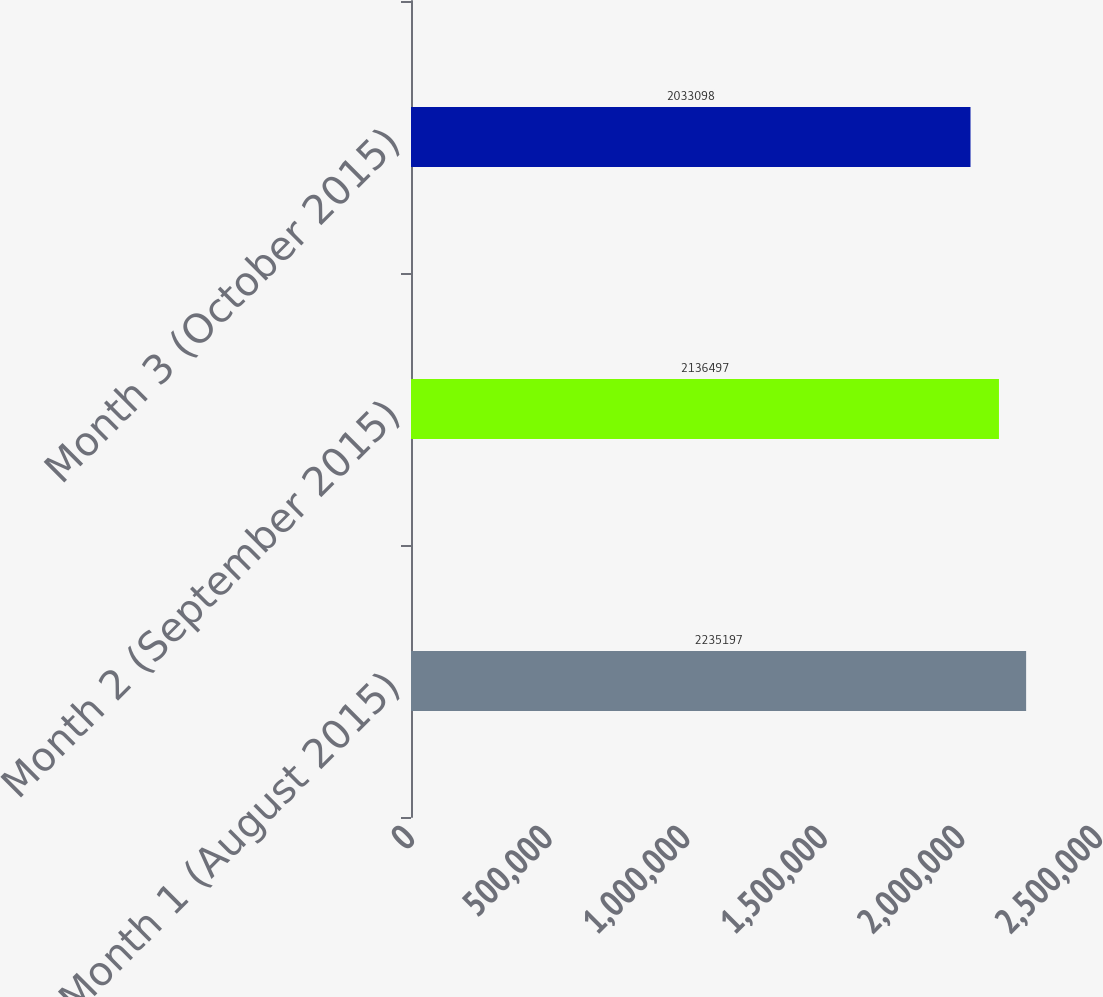Convert chart to OTSL. <chart><loc_0><loc_0><loc_500><loc_500><bar_chart><fcel>Month 1 (August 2015)<fcel>Month 2 (September 2015)<fcel>Month 3 (October 2015)<nl><fcel>2.2352e+06<fcel>2.1365e+06<fcel>2.0331e+06<nl></chart> 